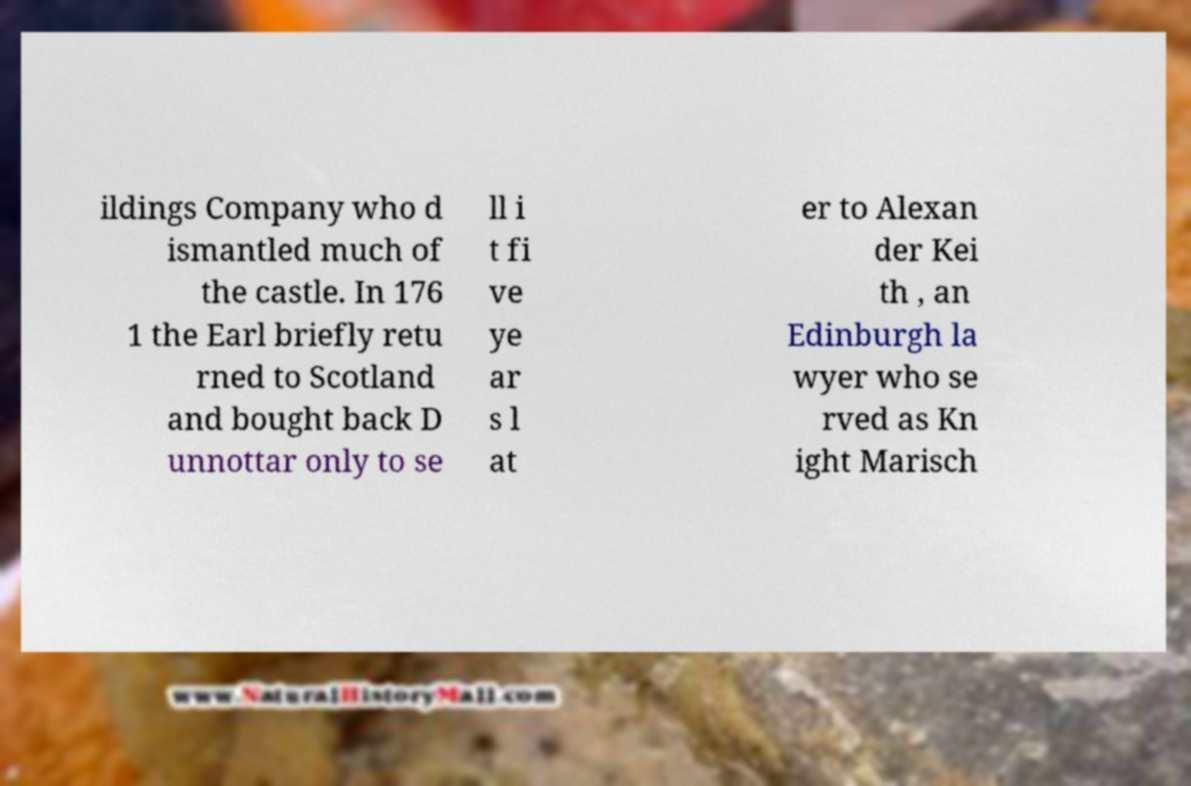Please identify and transcribe the text found in this image. ildings Company who d ismantled much of the castle. In 176 1 the Earl briefly retu rned to Scotland and bought back D unnottar only to se ll i t fi ve ye ar s l at er to Alexan der Kei th , an Edinburgh la wyer who se rved as Kn ight Marisch 